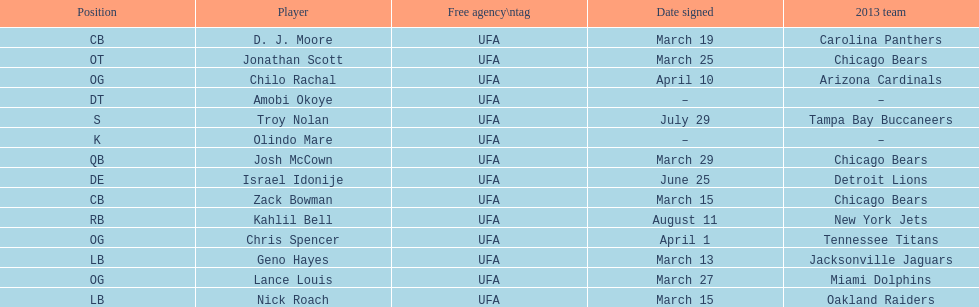Geno hayes and nick roach both played which position? LB. 